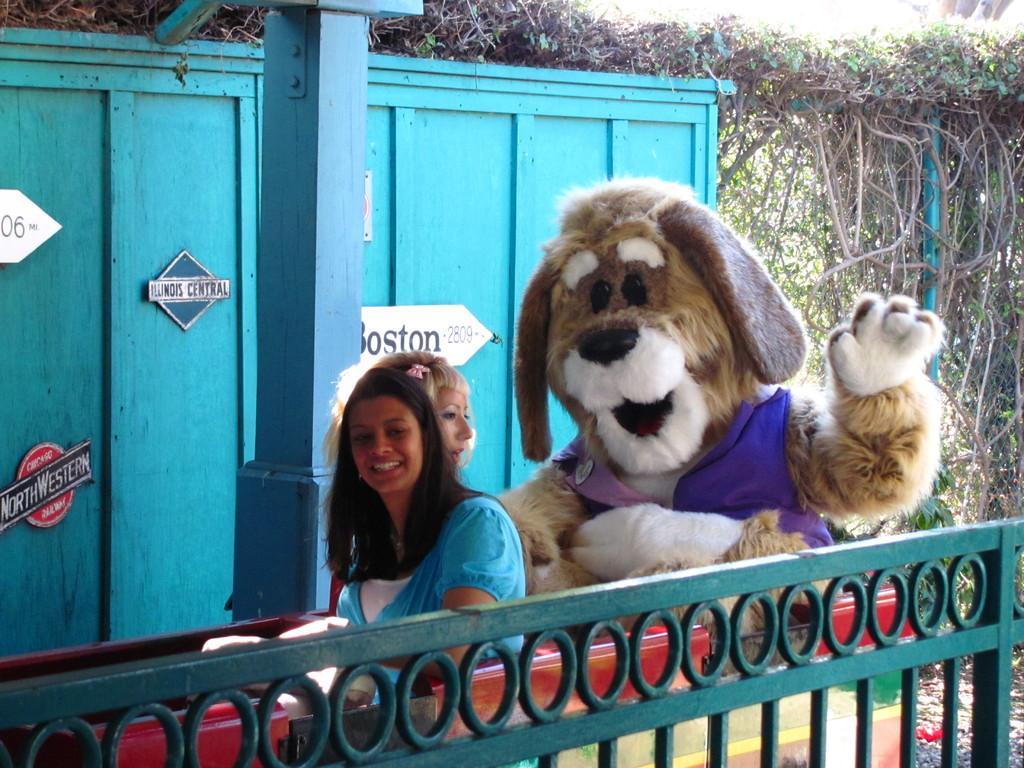Could you give a brief overview of what you see in this image? In this image, we can see a metal grill. In the middle of the image, we can see two women sitting. On the right side, we can see a person wearing a mask, trees, plants, pole. In the background, we can see a pillar and a blue color wall. 